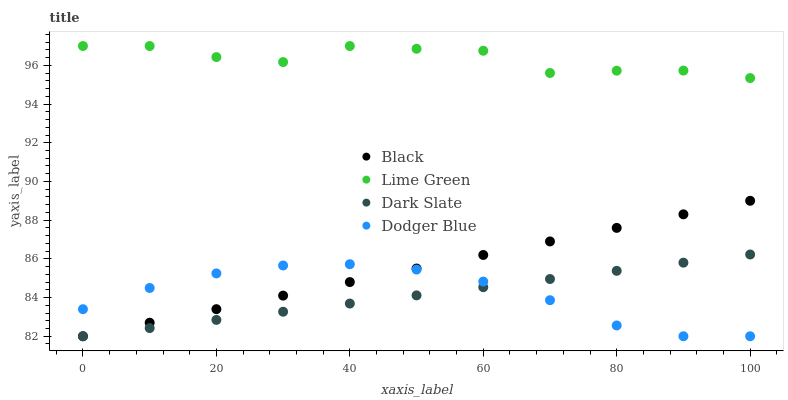Does Dark Slate have the minimum area under the curve?
Answer yes or no. Yes. Does Lime Green have the maximum area under the curve?
Answer yes or no. Yes. Does Black have the minimum area under the curve?
Answer yes or no. No. Does Black have the maximum area under the curve?
Answer yes or no. No. Is Dark Slate the smoothest?
Answer yes or no. Yes. Is Lime Green the roughest?
Answer yes or no. Yes. Is Black the smoothest?
Answer yes or no. No. Is Black the roughest?
Answer yes or no. No. Does Black have the lowest value?
Answer yes or no. Yes. Does Lime Green have the highest value?
Answer yes or no. Yes. Does Black have the highest value?
Answer yes or no. No. Is Black less than Lime Green?
Answer yes or no. Yes. Is Lime Green greater than Dark Slate?
Answer yes or no. Yes. Does Dodger Blue intersect Dark Slate?
Answer yes or no. Yes. Is Dodger Blue less than Dark Slate?
Answer yes or no. No. Is Dodger Blue greater than Dark Slate?
Answer yes or no. No. Does Black intersect Lime Green?
Answer yes or no. No. 